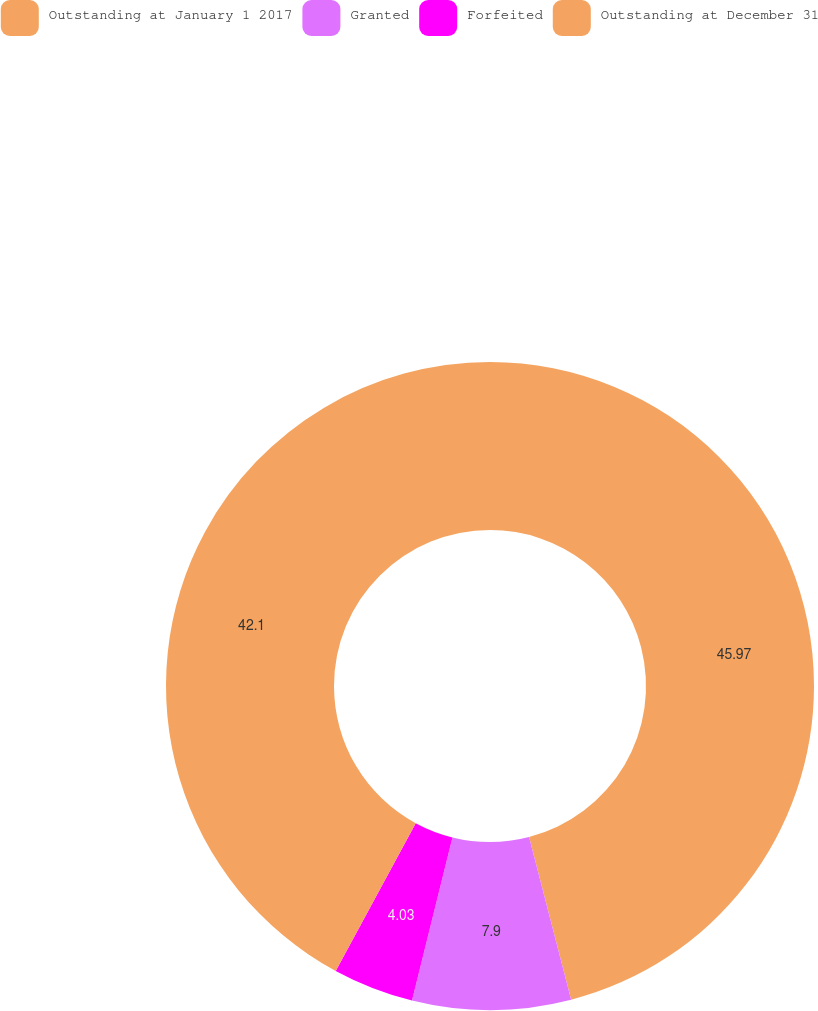Convert chart. <chart><loc_0><loc_0><loc_500><loc_500><pie_chart><fcel>Outstanding at January 1 2017<fcel>Granted<fcel>Forfeited<fcel>Outstanding at December 31<nl><fcel>45.97%<fcel>7.9%<fcel>4.03%<fcel>42.1%<nl></chart> 